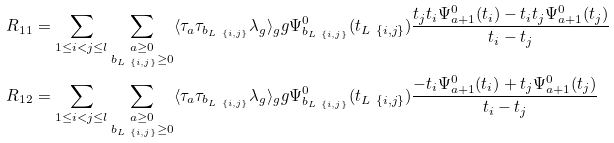<formula> <loc_0><loc_0><loc_500><loc_500>& R _ { 1 1 } = \sum _ { 1 \leq i < j \leq l } \sum _ { \substack { a \geq 0 \\ b _ { L \ \{ i , j \} } \geq 0 } } \langle \tau _ { a } \tau _ { b _ { L \ \{ i , j \} } } \lambda _ { g } \rangle _ { g } g \Psi _ { b _ { L \ \{ i , j \} } } ^ { 0 } ( t _ { L \ \{ i , j \} } ) \frac { t _ { j } t _ { i } \Psi _ { a + 1 } ^ { 0 } ( t _ { i } ) - t _ { i } t _ { j } \Psi _ { a + 1 } ^ { 0 } ( t _ { j } ) } { t _ { i } - t _ { j } } \\ & R _ { 1 2 } = \sum _ { 1 \leq i < j \leq l } \sum _ { \substack { a \geq 0 \\ b _ { L \ \{ i , j \} } \geq 0 } } \langle \tau _ { a } \tau _ { b _ { L \ \{ i , j \} } } \lambda _ { g } \rangle _ { g } g \Psi _ { b _ { L \ \{ i , j \} } } ^ { 0 } ( t _ { L \ \{ i , j \} } ) \frac { - t _ { i } \Psi _ { a + 1 } ^ { 0 } ( t _ { i } ) + t _ { j } \Psi _ { a + 1 } ^ { 0 } ( t _ { j } ) } { t _ { i } - t _ { j } }</formula> 